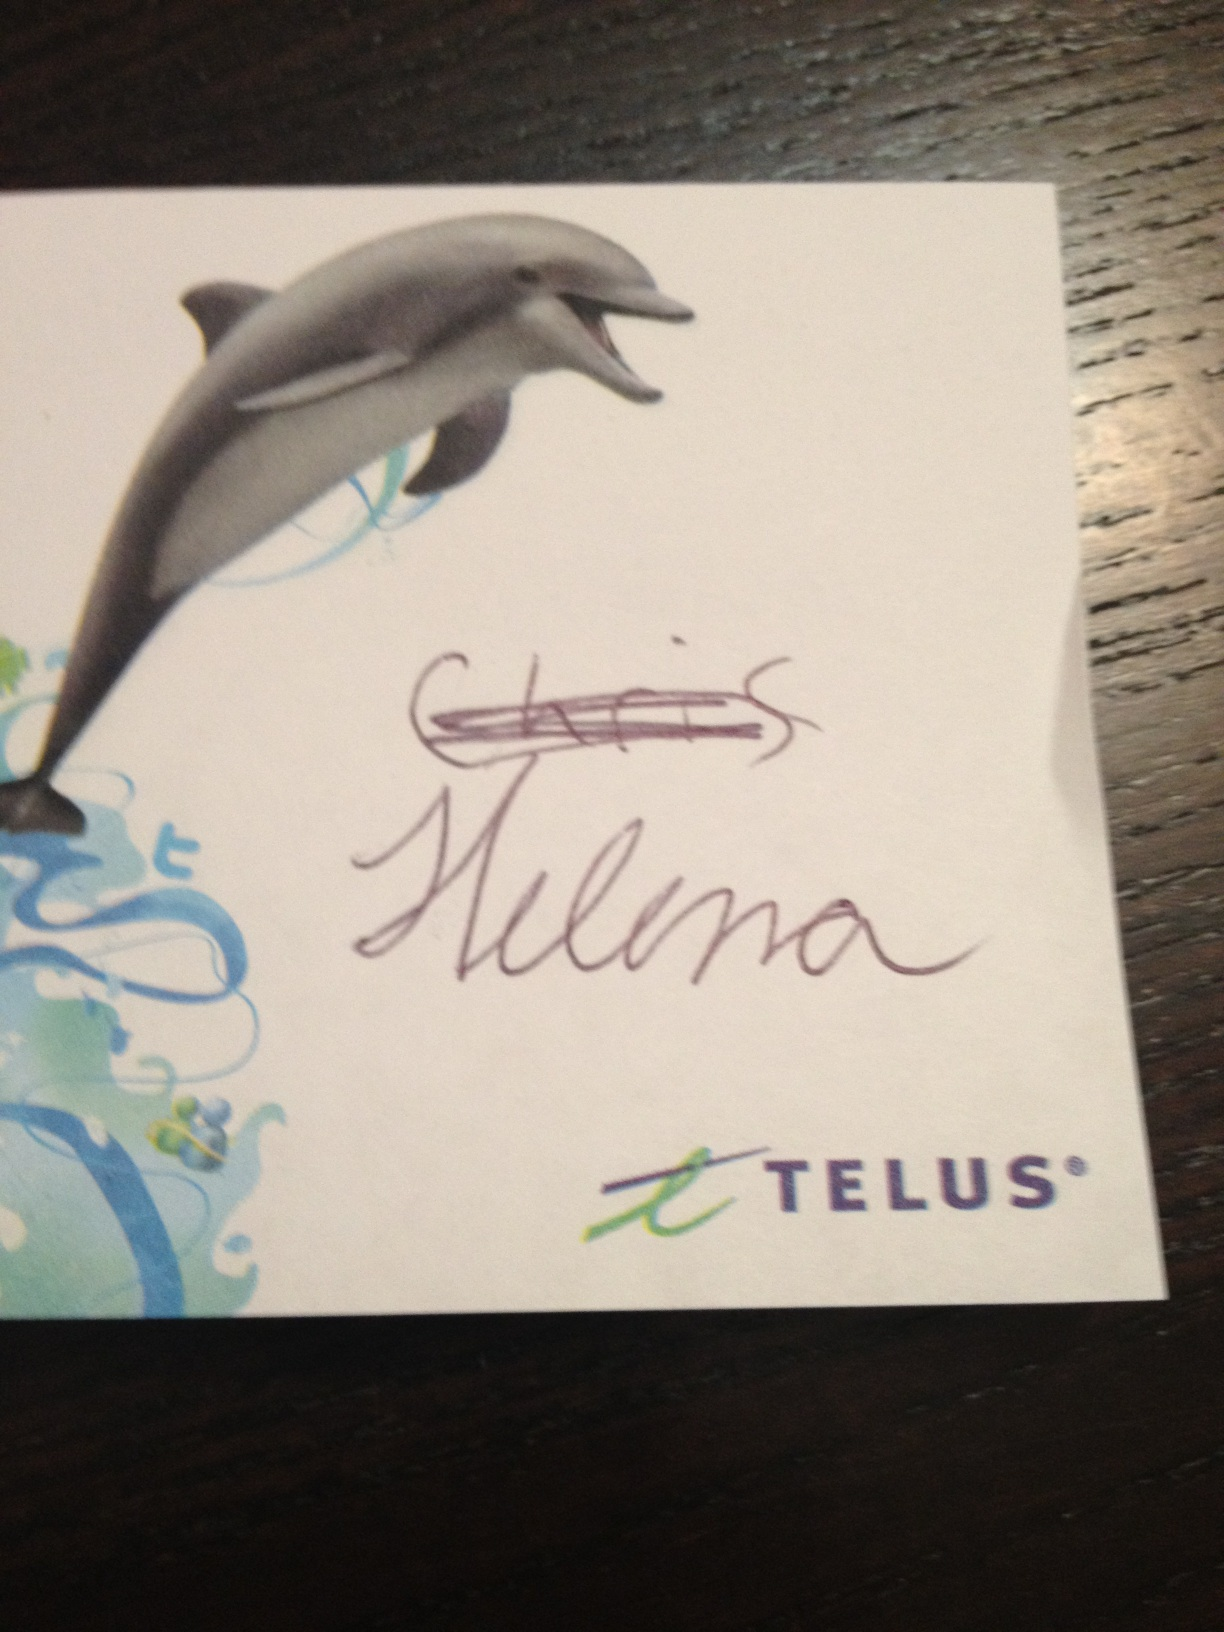What does this say? The image shows a promotional card featuring a drawing of a dolphin. The handwritten inscription reads 'Chris Helena' followed by the logo of Telus, a well-known telecommunications company. This suggests that the card may be a personalized or promotional item associated with or distributed by Telus. 